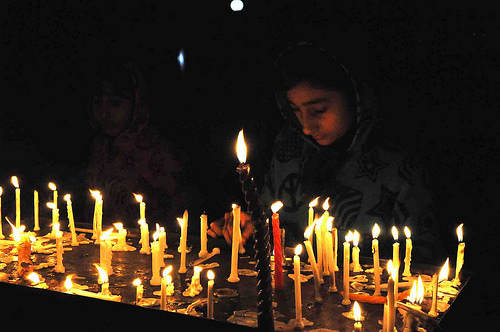<image>
Is the candle on the table? Yes. Looking at the image, I can see the candle is positioned on top of the table, with the table providing support. Is there a candle to the right of the candle? Yes. From this viewpoint, the candle is positioned to the right side relative to the candle. Where is the candle in relation to the candle? Is it to the right of the candle? Yes. From this viewpoint, the candle is positioned to the right side relative to the candle. 